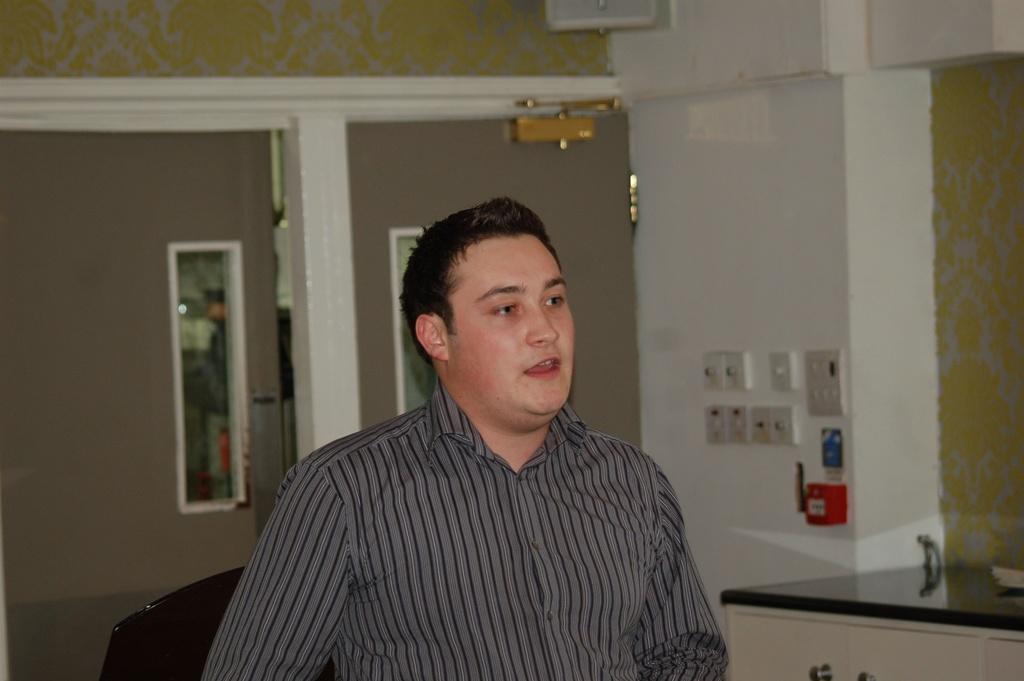Could you give a brief overview of what you see in this image? In this image we can see a person. We can also see a table with a cupboard, some mirrors and the switch boards to a wall. 